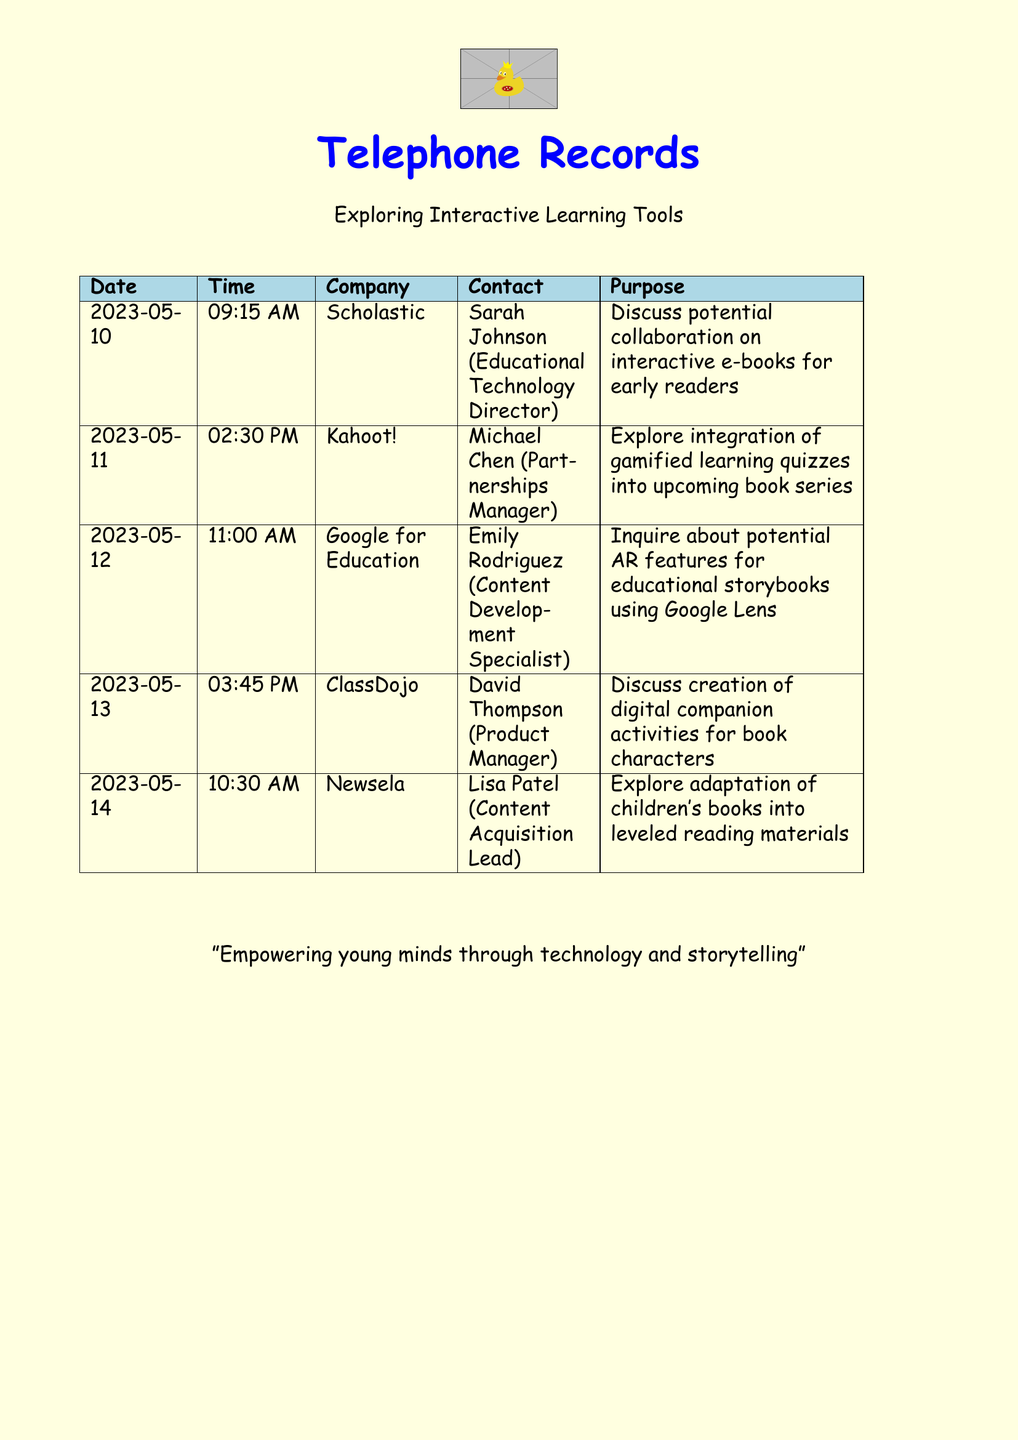What is the date of the call to Scholastic? The date of the call to Scholastic is the first entry in the document, which is 2023-05-10.
Answer: 2023-05-10 Who is the contact at Kahoot!? The contact for Kahoot! is the person listed in the second entry, which is Michael Chen.
Answer: Michael Chen What was discussed in the call with ClassDojo? The discussion topic with ClassDojo is noted in the fourth entry, which is about digital companion activities for book characters.
Answer: Digital companion activities for book characters How many companies were contacted regarding educational technology? The number of unique companies listed is counted from the entries, which totals five distinct companies.
Answer: 5 What time was the call with Google for Education? The time of the call with Google for Education is stated in the third entry, which is 11:00 AM.
Answer: 11:00 AM What is the purpose of the call with Newsela? The purpose of the call with Newsela is described in the fifth entry, which is exploring the adaptation of children's books.
Answer: Explore adaptation of children's books Which company contacted on 2023-05-12? The company contacted on that date is noted in the third entry, which is Google for Education.
Answer: Google for Education Who is the Educational Technology Director at Scholastic? The title of the individual from Scholastic is mentioned in the first entry, which is Sarah Johnson.
Answer: Sarah Johnson 